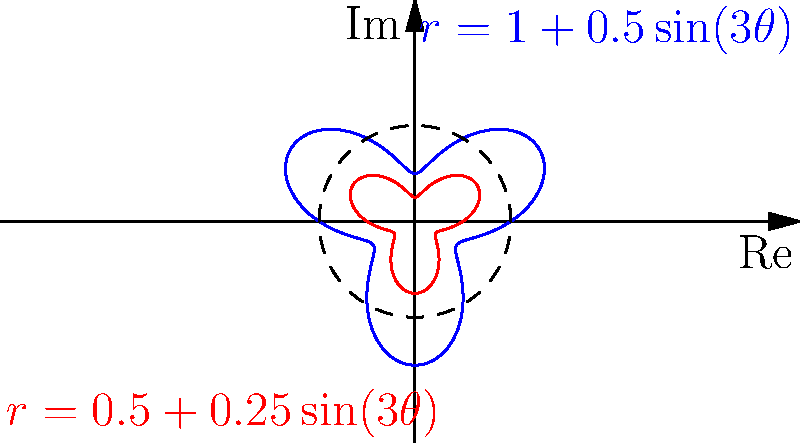The polar graphs shown represent sound waves of two different musical notes. The blue curve is described by the equation $r = 1 + 0.5\sin(3\theta)$, while the red curve is a scaled version of the blue one. What musical interval do these two waves likely represent, and how does this relate to the concept of harmonic overtones in music theory? To answer this question, let's follow these steps:

1. Observe the equations:
   Blue curve: $r = 1 + 0.5\sin(3\theta)$
   Red curve: Scaled version of the blue curve

2. The red curve appears to be exactly half the size of the blue curve. This suggests that its equation is:
   $r = 0.5 + 0.25\sin(3\theta)$

3. In music theory, when the frequency of one note is exactly double that of another, they form an octave. The relationship between the two curves suggests an octave interval.

4. The factor of 3 in $\sin(3\theta)$ represents the third harmonic overtone. In music, overtones are integer multiples of the fundamental frequency and contribute to the timbre of a sound.

5. The presence of the third harmonic is significant in music theory:
   - It reinforces the perception of the fundamental frequency
   - It contributes to the richness and brightness of the tone
   - It's particularly strong in many musical instruments, especially brass and woodwinds

6. The amplitude of the sine term (0.5 and 0.25 for blue and red curves respectively) represents the strength of this third harmonic relative to the fundamental frequency (represented by the constant terms 1 and 0.5).

7. This representation demonstrates how complex tones in music can be modeled as a combination of simple sinusoidal waves, which is the basis of Fourier analysis in both mathematics and music theory.
Answer: Octave interval; third harmonic overtone 